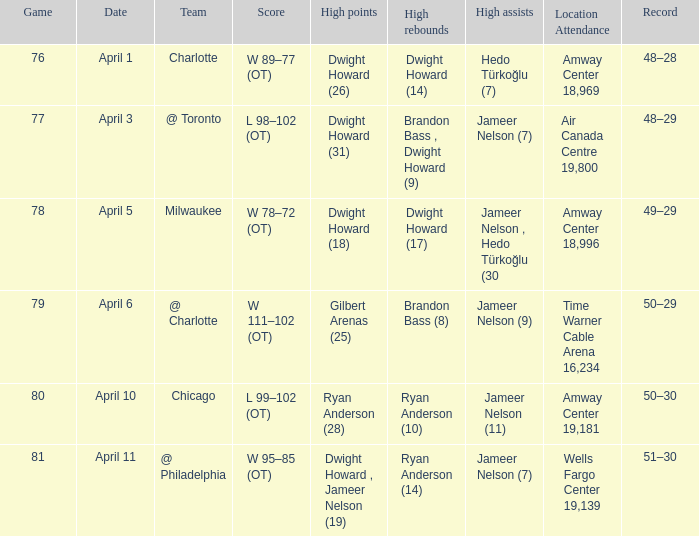What was the location of the game and the attendance figure on april 3? Air Canada Centre 19,800. 